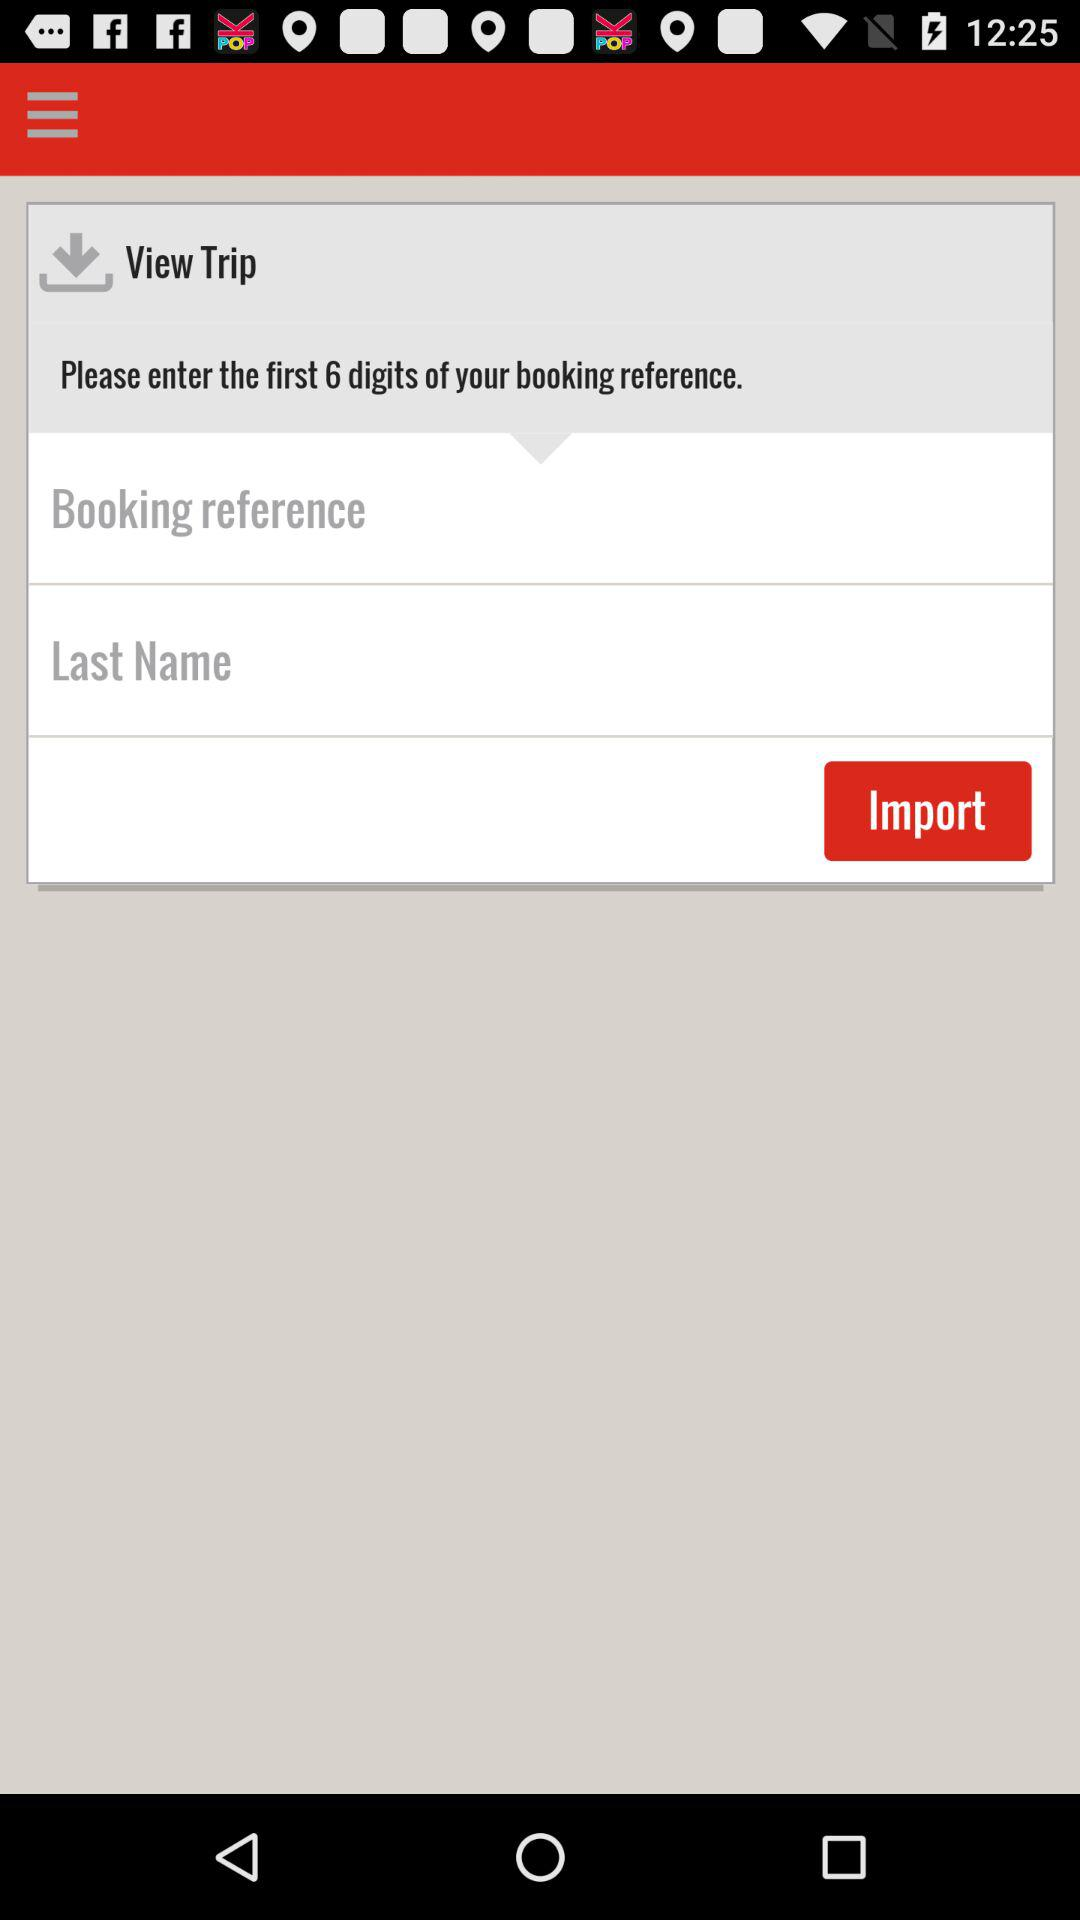How many digits were used for your booking reference number? The digits used were 6. 